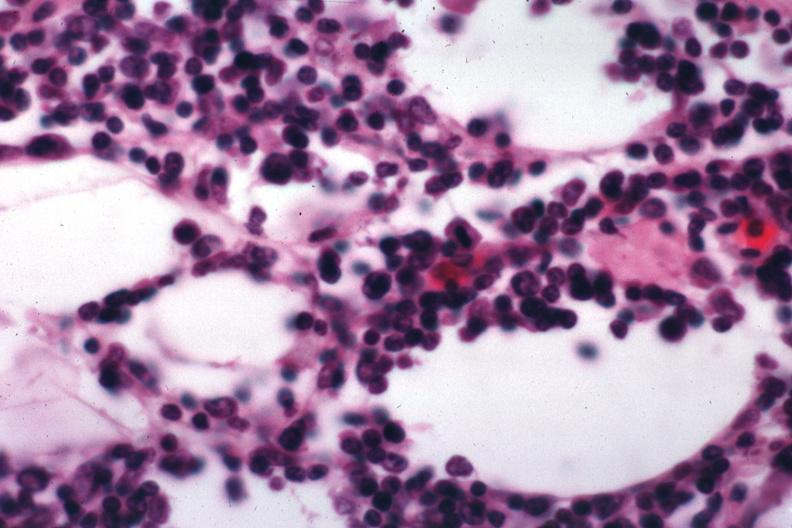s malignant lymphoma present?
Answer the question using a single word or phrase. Yes 